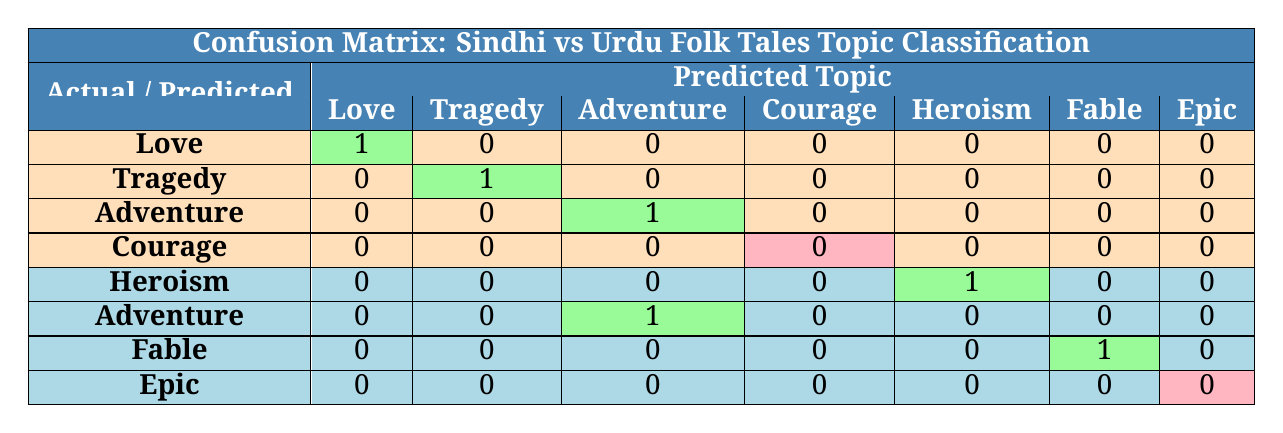What is the predicted topic for "Qissa Chadar"? The row for "Qissa Chadar" indicates that the predicted topic is "Justice." This is seen in the fourth row, under the predicted column for "Courage," which is marked as incorrect.
Answer: Justice How many Sindhi folk tales were predicted correctly? The table shows three Sindhi folk tales—"Heer Ranjha," "Mirza Sahiban," and "Sassi Punnun"—with each having a correct prediction. Summing these gives 3 correct predictions.
Answer: 3 What is the total number of folk tales analyzed in this confusion matrix? Counting each tale from the ground truth, there are 4 Sindhi folk tales and 4 Urdu folk tales. The total is 4 + 4 = 8 folk tales.
Answer: 8 Were any predictions made for the topic of "Courage"? In the table, the prediction for the actual topic "Courage" indicates incorrect predictions (0). Thus, there were no correct predictions made for this topic.
Answer: No Which Urdu folk tale had an incorrect prediction and what was it? The "Shahnameh" had an incorrect prediction marked as "Legendary," indicated in the row for "Epic." Thus, it was misclassified.
Answer: Shahnameh What is the accuracy of topic classification for Urdu folk tales? The correct predictions for Urdu folk tales include "Heroism," "Adventure," and "Fable," that is 3 correct out of 4 total. Accuracy is calculated as 3/4 = 0.75 or 75%.
Answer: 75% What can be inferred about the prediction for "Sassi Punnun"? The prediction for "Sassi Punnun" shows that it was predicted correctly with the topic "Adventure," which is indicated in the third row with a correct prediction.
Answer: Correct Which topic had the highest number of correct predictions across all tales? By examining the correct predictions, the topics "Love," "Tragedy," "Adventure," and "Heroism" each have one correct prediction. Therefore, none had a higher count; they are equal.
Answer: All are equal 